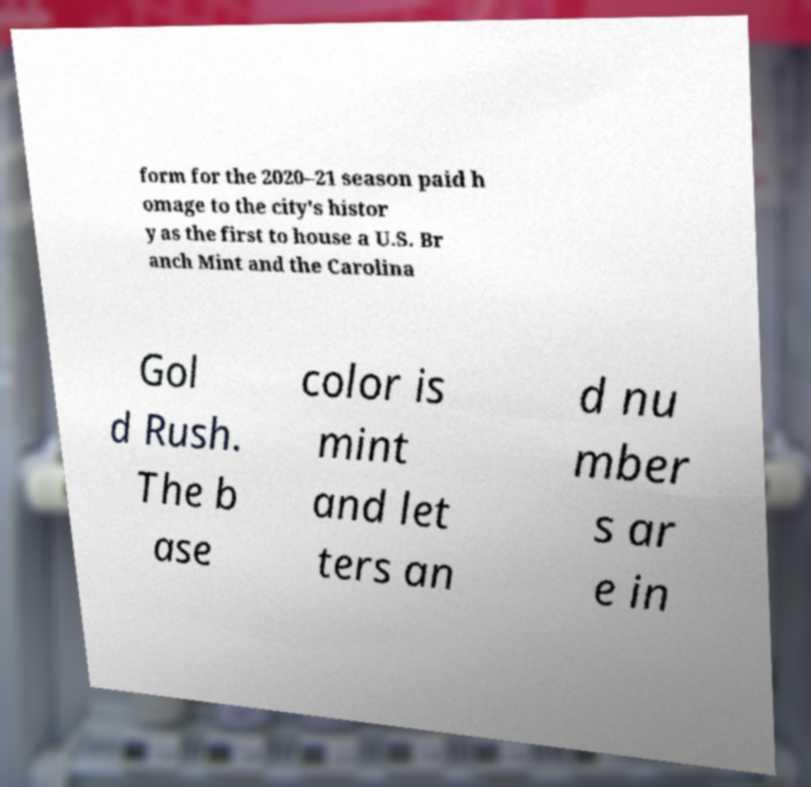I need the written content from this picture converted into text. Can you do that? form for the 2020–21 season paid h omage to the city's histor y as the first to house a U.S. Br anch Mint and the Carolina Gol d Rush. The b ase color is mint and let ters an d nu mber s ar e in 